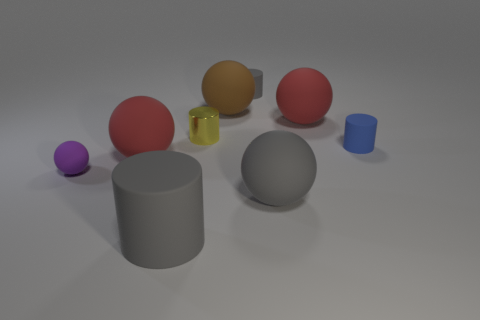Is there any other thing that is the same material as the small yellow object?
Provide a succinct answer. No. What number of balls are on the right side of the big brown object?
Offer a very short reply. 2. Are there the same number of tiny yellow metal things in front of the small purple matte sphere and gray rubber cylinders that are behind the tiny gray rubber thing?
Provide a short and direct response. Yes. There is a blue object that is the same shape as the yellow shiny object; what is its size?
Make the answer very short. Small. The gray matte thing behind the tiny purple thing has what shape?
Ensure brevity in your answer.  Cylinder. Are the red object that is on the left side of the gray ball and the gray cylinder that is in front of the purple sphere made of the same material?
Ensure brevity in your answer.  Yes. What is the shape of the yellow metallic object?
Provide a short and direct response. Cylinder. Are there the same number of tiny matte cylinders that are left of the big brown thing and small yellow metallic cubes?
Ensure brevity in your answer.  Yes. What is the size of the sphere that is the same color as the big matte cylinder?
Offer a very short reply. Large. Are there any yellow spheres made of the same material as the tiny gray thing?
Provide a short and direct response. No. 